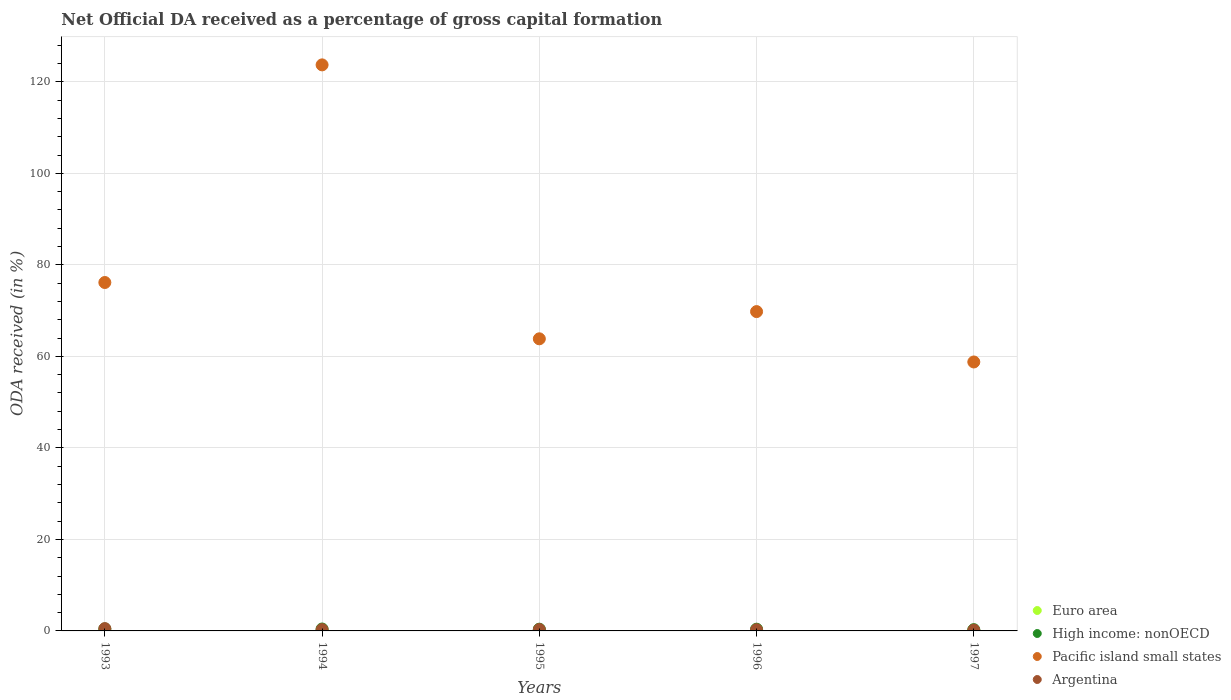How many different coloured dotlines are there?
Your answer should be compact. 4. What is the net ODA received in Argentina in 1997?
Provide a short and direct response. 0.18. Across all years, what is the maximum net ODA received in Argentina?
Offer a terse response. 0.5. Across all years, what is the minimum net ODA received in High income: nonOECD?
Provide a succinct answer. 0.28. In which year was the net ODA received in Euro area maximum?
Provide a succinct answer. 1996. In which year was the net ODA received in Euro area minimum?
Your answer should be compact. 1995. What is the total net ODA received in High income: nonOECD in the graph?
Your answer should be very brief. 1.9. What is the difference between the net ODA received in High income: nonOECD in 1994 and that in 1997?
Your response must be concise. 0.14. What is the difference between the net ODA received in Pacific island small states in 1994 and the net ODA received in Argentina in 1997?
Give a very brief answer. 123.53. What is the average net ODA received in Argentina per year?
Offer a very short reply. 0.31. In the year 1995, what is the difference between the net ODA received in Argentina and net ODA received in Pacific island small states?
Offer a terse response. -63.53. In how many years, is the net ODA received in High income: nonOECD greater than 72 %?
Offer a terse response. 0. What is the ratio of the net ODA received in Euro area in 1994 to that in 1996?
Make the answer very short. 0.77. What is the difference between the highest and the second highest net ODA received in Argentina?
Offer a terse response. 0.19. What is the difference between the highest and the lowest net ODA received in Euro area?
Your response must be concise. 0.01. In how many years, is the net ODA received in Euro area greater than the average net ODA received in Euro area taken over all years?
Keep it short and to the point. 3. Is the sum of the net ODA received in Pacific island small states in 1993 and 1997 greater than the maximum net ODA received in Argentina across all years?
Give a very brief answer. Yes. Is it the case that in every year, the sum of the net ODA received in Argentina and net ODA received in Pacific island small states  is greater than the net ODA received in High income: nonOECD?
Provide a succinct answer. Yes. How many years are there in the graph?
Give a very brief answer. 5. What is the difference between two consecutive major ticks on the Y-axis?
Your response must be concise. 20. Are the values on the major ticks of Y-axis written in scientific E-notation?
Ensure brevity in your answer.  No. Does the graph contain any zero values?
Give a very brief answer. No. Does the graph contain grids?
Offer a very short reply. Yes. Where does the legend appear in the graph?
Keep it short and to the point. Bottom right. How many legend labels are there?
Provide a short and direct response. 4. What is the title of the graph?
Ensure brevity in your answer.  Net Official DA received as a percentage of gross capital formation. Does "Switzerland" appear as one of the legend labels in the graph?
Ensure brevity in your answer.  No. What is the label or title of the X-axis?
Give a very brief answer. Years. What is the label or title of the Y-axis?
Provide a short and direct response. ODA received (in %). What is the ODA received (in %) in Euro area in 1993?
Provide a succinct answer. 0.01. What is the ODA received (in %) in High income: nonOECD in 1993?
Make the answer very short. 0.44. What is the ODA received (in %) in Pacific island small states in 1993?
Provide a short and direct response. 76.15. What is the ODA received (in %) of Argentina in 1993?
Provide a short and direct response. 0.5. What is the ODA received (in %) in Euro area in 1994?
Provide a succinct answer. 0.01. What is the ODA received (in %) of High income: nonOECD in 1994?
Your response must be concise. 0.42. What is the ODA received (in %) of Pacific island small states in 1994?
Your response must be concise. 123.71. What is the ODA received (in %) of Argentina in 1994?
Provide a succinct answer. 0.28. What is the ODA received (in %) in Euro area in 1995?
Provide a succinct answer. 0.01. What is the ODA received (in %) of High income: nonOECD in 1995?
Ensure brevity in your answer.  0.38. What is the ODA received (in %) of Pacific island small states in 1995?
Your answer should be very brief. 63.84. What is the ODA received (in %) of Argentina in 1995?
Your answer should be very brief. 0.31. What is the ODA received (in %) of Euro area in 1996?
Your answer should be very brief. 0.01. What is the ODA received (in %) in High income: nonOECD in 1996?
Provide a short and direct response. 0.38. What is the ODA received (in %) of Pacific island small states in 1996?
Give a very brief answer. 69.79. What is the ODA received (in %) of Argentina in 1996?
Ensure brevity in your answer.  0.27. What is the ODA received (in %) in Euro area in 1997?
Make the answer very short. 0.01. What is the ODA received (in %) in High income: nonOECD in 1997?
Offer a terse response. 0.28. What is the ODA received (in %) in Pacific island small states in 1997?
Provide a short and direct response. 58.78. What is the ODA received (in %) of Argentina in 1997?
Your response must be concise. 0.18. Across all years, what is the maximum ODA received (in %) of Euro area?
Ensure brevity in your answer.  0.01. Across all years, what is the maximum ODA received (in %) of High income: nonOECD?
Give a very brief answer. 0.44. Across all years, what is the maximum ODA received (in %) of Pacific island small states?
Your answer should be very brief. 123.71. Across all years, what is the maximum ODA received (in %) of Argentina?
Keep it short and to the point. 0.5. Across all years, what is the minimum ODA received (in %) of Euro area?
Ensure brevity in your answer.  0.01. Across all years, what is the minimum ODA received (in %) of High income: nonOECD?
Your response must be concise. 0.28. Across all years, what is the minimum ODA received (in %) in Pacific island small states?
Provide a short and direct response. 58.78. Across all years, what is the minimum ODA received (in %) in Argentina?
Give a very brief answer. 0.18. What is the total ODA received (in %) in Euro area in the graph?
Your answer should be compact. 0.04. What is the total ODA received (in %) of High income: nonOECD in the graph?
Offer a very short reply. 1.9. What is the total ODA received (in %) of Pacific island small states in the graph?
Give a very brief answer. 392.26. What is the total ODA received (in %) of Argentina in the graph?
Provide a succinct answer. 1.54. What is the difference between the ODA received (in %) of Euro area in 1993 and that in 1994?
Provide a succinct answer. -0. What is the difference between the ODA received (in %) of High income: nonOECD in 1993 and that in 1994?
Your response must be concise. 0.02. What is the difference between the ODA received (in %) of Pacific island small states in 1993 and that in 1994?
Your response must be concise. -47.56. What is the difference between the ODA received (in %) in Argentina in 1993 and that in 1994?
Your answer should be compact. 0.22. What is the difference between the ODA received (in %) of High income: nonOECD in 1993 and that in 1995?
Provide a short and direct response. 0.06. What is the difference between the ODA received (in %) of Pacific island small states in 1993 and that in 1995?
Make the answer very short. 12.31. What is the difference between the ODA received (in %) of Argentina in 1993 and that in 1995?
Provide a short and direct response. 0.19. What is the difference between the ODA received (in %) of Euro area in 1993 and that in 1996?
Your answer should be compact. -0.01. What is the difference between the ODA received (in %) of High income: nonOECD in 1993 and that in 1996?
Your answer should be compact. 0.06. What is the difference between the ODA received (in %) of Pacific island small states in 1993 and that in 1996?
Offer a terse response. 6.36. What is the difference between the ODA received (in %) of Argentina in 1993 and that in 1996?
Make the answer very short. 0.24. What is the difference between the ODA received (in %) of Euro area in 1993 and that in 1997?
Make the answer very short. -0. What is the difference between the ODA received (in %) of High income: nonOECD in 1993 and that in 1997?
Give a very brief answer. 0.16. What is the difference between the ODA received (in %) of Pacific island small states in 1993 and that in 1997?
Provide a succinct answer. 17.37. What is the difference between the ODA received (in %) of Argentina in 1993 and that in 1997?
Give a very brief answer. 0.32. What is the difference between the ODA received (in %) of Euro area in 1994 and that in 1995?
Ensure brevity in your answer.  0. What is the difference between the ODA received (in %) of High income: nonOECD in 1994 and that in 1995?
Offer a terse response. 0.04. What is the difference between the ODA received (in %) in Pacific island small states in 1994 and that in 1995?
Give a very brief answer. 59.87. What is the difference between the ODA received (in %) in Argentina in 1994 and that in 1995?
Offer a terse response. -0.02. What is the difference between the ODA received (in %) in Euro area in 1994 and that in 1996?
Provide a short and direct response. -0. What is the difference between the ODA received (in %) in High income: nonOECD in 1994 and that in 1996?
Offer a terse response. 0.04. What is the difference between the ODA received (in %) in Pacific island small states in 1994 and that in 1996?
Give a very brief answer. 53.92. What is the difference between the ODA received (in %) in Argentina in 1994 and that in 1996?
Ensure brevity in your answer.  0.02. What is the difference between the ODA received (in %) in Euro area in 1994 and that in 1997?
Make the answer very short. 0. What is the difference between the ODA received (in %) of High income: nonOECD in 1994 and that in 1997?
Provide a short and direct response. 0.14. What is the difference between the ODA received (in %) of Pacific island small states in 1994 and that in 1997?
Your answer should be compact. 64.93. What is the difference between the ODA received (in %) of Argentina in 1994 and that in 1997?
Offer a very short reply. 0.1. What is the difference between the ODA received (in %) of Euro area in 1995 and that in 1996?
Provide a short and direct response. -0.01. What is the difference between the ODA received (in %) of High income: nonOECD in 1995 and that in 1996?
Provide a succinct answer. -0. What is the difference between the ODA received (in %) of Pacific island small states in 1995 and that in 1996?
Your answer should be very brief. -5.95. What is the difference between the ODA received (in %) in Argentina in 1995 and that in 1996?
Keep it short and to the point. 0.04. What is the difference between the ODA received (in %) in Euro area in 1995 and that in 1997?
Make the answer very short. -0. What is the difference between the ODA received (in %) of High income: nonOECD in 1995 and that in 1997?
Offer a very short reply. 0.1. What is the difference between the ODA received (in %) of Pacific island small states in 1995 and that in 1997?
Provide a succinct answer. 5.06. What is the difference between the ODA received (in %) in Argentina in 1995 and that in 1997?
Provide a succinct answer. 0.13. What is the difference between the ODA received (in %) in Euro area in 1996 and that in 1997?
Your response must be concise. 0. What is the difference between the ODA received (in %) in High income: nonOECD in 1996 and that in 1997?
Keep it short and to the point. 0.1. What is the difference between the ODA received (in %) in Pacific island small states in 1996 and that in 1997?
Offer a terse response. 11.01. What is the difference between the ODA received (in %) of Argentina in 1996 and that in 1997?
Provide a short and direct response. 0.09. What is the difference between the ODA received (in %) of Euro area in 1993 and the ODA received (in %) of High income: nonOECD in 1994?
Give a very brief answer. -0.41. What is the difference between the ODA received (in %) in Euro area in 1993 and the ODA received (in %) in Pacific island small states in 1994?
Your answer should be very brief. -123.7. What is the difference between the ODA received (in %) of Euro area in 1993 and the ODA received (in %) of Argentina in 1994?
Ensure brevity in your answer.  -0.28. What is the difference between the ODA received (in %) in High income: nonOECD in 1993 and the ODA received (in %) in Pacific island small states in 1994?
Your answer should be very brief. -123.27. What is the difference between the ODA received (in %) in High income: nonOECD in 1993 and the ODA received (in %) in Argentina in 1994?
Provide a succinct answer. 0.15. What is the difference between the ODA received (in %) in Pacific island small states in 1993 and the ODA received (in %) in Argentina in 1994?
Keep it short and to the point. 75.86. What is the difference between the ODA received (in %) in Euro area in 1993 and the ODA received (in %) in High income: nonOECD in 1995?
Offer a very short reply. -0.37. What is the difference between the ODA received (in %) of Euro area in 1993 and the ODA received (in %) of Pacific island small states in 1995?
Your answer should be very brief. -63.83. What is the difference between the ODA received (in %) of Euro area in 1993 and the ODA received (in %) of Argentina in 1995?
Make the answer very short. -0.3. What is the difference between the ODA received (in %) in High income: nonOECD in 1993 and the ODA received (in %) in Pacific island small states in 1995?
Offer a terse response. -63.4. What is the difference between the ODA received (in %) in High income: nonOECD in 1993 and the ODA received (in %) in Argentina in 1995?
Give a very brief answer. 0.13. What is the difference between the ODA received (in %) of Pacific island small states in 1993 and the ODA received (in %) of Argentina in 1995?
Make the answer very short. 75.84. What is the difference between the ODA received (in %) of Euro area in 1993 and the ODA received (in %) of High income: nonOECD in 1996?
Provide a succinct answer. -0.38. What is the difference between the ODA received (in %) in Euro area in 1993 and the ODA received (in %) in Pacific island small states in 1996?
Offer a very short reply. -69.78. What is the difference between the ODA received (in %) of Euro area in 1993 and the ODA received (in %) of Argentina in 1996?
Your answer should be compact. -0.26. What is the difference between the ODA received (in %) in High income: nonOECD in 1993 and the ODA received (in %) in Pacific island small states in 1996?
Ensure brevity in your answer.  -69.35. What is the difference between the ODA received (in %) in High income: nonOECD in 1993 and the ODA received (in %) in Argentina in 1996?
Give a very brief answer. 0.17. What is the difference between the ODA received (in %) of Pacific island small states in 1993 and the ODA received (in %) of Argentina in 1996?
Your answer should be compact. 75.88. What is the difference between the ODA received (in %) of Euro area in 1993 and the ODA received (in %) of High income: nonOECD in 1997?
Provide a succinct answer. -0.27. What is the difference between the ODA received (in %) of Euro area in 1993 and the ODA received (in %) of Pacific island small states in 1997?
Ensure brevity in your answer.  -58.77. What is the difference between the ODA received (in %) in Euro area in 1993 and the ODA received (in %) in Argentina in 1997?
Your answer should be compact. -0.17. What is the difference between the ODA received (in %) in High income: nonOECD in 1993 and the ODA received (in %) in Pacific island small states in 1997?
Give a very brief answer. -58.34. What is the difference between the ODA received (in %) in High income: nonOECD in 1993 and the ODA received (in %) in Argentina in 1997?
Your response must be concise. 0.26. What is the difference between the ODA received (in %) in Pacific island small states in 1993 and the ODA received (in %) in Argentina in 1997?
Give a very brief answer. 75.97. What is the difference between the ODA received (in %) in Euro area in 1994 and the ODA received (in %) in High income: nonOECD in 1995?
Your answer should be compact. -0.37. What is the difference between the ODA received (in %) in Euro area in 1994 and the ODA received (in %) in Pacific island small states in 1995?
Ensure brevity in your answer.  -63.83. What is the difference between the ODA received (in %) in Euro area in 1994 and the ODA received (in %) in Argentina in 1995?
Offer a terse response. -0.3. What is the difference between the ODA received (in %) of High income: nonOECD in 1994 and the ODA received (in %) of Pacific island small states in 1995?
Provide a short and direct response. -63.42. What is the difference between the ODA received (in %) in High income: nonOECD in 1994 and the ODA received (in %) in Argentina in 1995?
Offer a very short reply. 0.11. What is the difference between the ODA received (in %) in Pacific island small states in 1994 and the ODA received (in %) in Argentina in 1995?
Make the answer very short. 123.4. What is the difference between the ODA received (in %) of Euro area in 1994 and the ODA received (in %) of High income: nonOECD in 1996?
Give a very brief answer. -0.37. What is the difference between the ODA received (in %) of Euro area in 1994 and the ODA received (in %) of Pacific island small states in 1996?
Your response must be concise. -69.78. What is the difference between the ODA received (in %) in Euro area in 1994 and the ODA received (in %) in Argentina in 1996?
Your answer should be very brief. -0.26. What is the difference between the ODA received (in %) in High income: nonOECD in 1994 and the ODA received (in %) in Pacific island small states in 1996?
Provide a short and direct response. -69.37. What is the difference between the ODA received (in %) in High income: nonOECD in 1994 and the ODA received (in %) in Argentina in 1996?
Offer a very short reply. 0.15. What is the difference between the ODA received (in %) of Pacific island small states in 1994 and the ODA received (in %) of Argentina in 1996?
Give a very brief answer. 123.44. What is the difference between the ODA received (in %) in Euro area in 1994 and the ODA received (in %) in High income: nonOECD in 1997?
Give a very brief answer. -0.27. What is the difference between the ODA received (in %) in Euro area in 1994 and the ODA received (in %) in Pacific island small states in 1997?
Offer a terse response. -58.77. What is the difference between the ODA received (in %) in Euro area in 1994 and the ODA received (in %) in Argentina in 1997?
Offer a very short reply. -0.17. What is the difference between the ODA received (in %) in High income: nonOECD in 1994 and the ODA received (in %) in Pacific island small states in 1997?
Keep it short and to the point. -58.36. What is the difference between the ODA received (in %) in High income: nonOECD in 1994 and the ODA received (in %) in Argentina in 1997?
Offer a terse response. 0.24. What is the difference between the ODA received (in %) in Pacific island small states in 1994 and the ODA received (in %) in Argentina in 1997?
Give a very brief answer. 123.53. What is the difference between the ODA received (in %) of Euro area in 1995 and the ODA received (in %) of High income: nonOECD in 1996?
Make the answer very short. -0.38. What is the difference between the ODA received (in %) in Euro area in 1995 and the ODA received (in %) in Pacific island small states in 1996?
Make the answer very short. -69.78. What is the difference between the ODA received (in %) of Euro area in 1995 and the ODA received (in %) of Argentina in 1996?
Offer a terse response. -0.26. What is the difference between the ODA received (in %) of High income: nonOECD in 1995 and the ODA received (in %) of Pacific island small states in 1996?
Your response must be concise. -69.41. What is the difference between the ODA received (in %) in High income: nonOECD in 1995 and the ODA received (in %) in Argentina in 1996?
Your response must be concise. 0.11. What is the difference between the ODA received (in %) of Pacific island small states in 1995 and the ODA received (in %) of Argentina in 1996?
Provide a succinct answer. 63.57. What is the difference between the ODA received (in %) of Euro area in 1995 and the ODA received (in %) of High income: nonOECD in 1997?
Keep it short and to the point. -0.27. What is the difference between the ODA received (in %) in Euro area in 1995 and the ODA received (in %) in Pacific island small states in 1997?
Your answer should be very brief. -58.77. What is the difference between the ODA received (in %) in Euro area in 1995 and the ODA received (in %) in Argentina in 1997?
Make the answer very short. -0.17. What is the difference between the ODA received (in %) of High income: nonOECD in 1995 and the ODA received (in %) of Pacific island small states in 1997?
Offer a very short reply. -58.4. What is the difference between the ODA received (in %) in High income: nonOECD in 1995 and the ODA received (in %) in Argentina in 1997?
Your answer should be compact. 0.2. What is the difference between the ODA received (in %) of Pacific island small states in 1995 and the ODA received (in %) of Argentina in 1997?
Keep it short and to the point. 63.66. What is the difference between the ODA received (in %) of Euro area in 1996 and the ODA received (in %) of High income: nonOECD in 1997?
Your answer should be compact. -0.27. What is the difference between the ODA received (in %) in Euro area in 1996 and the ODA received (in %) in Pacific island small states in 1997?
Offer a very short reply. -58.77. What is the difference between the ODA received (in %) of Euro area in 1996 and the ODA received (in %) of Argentina in 1997?
Give a very brief answer. -0.17. What is the difference between the ODA received (in %) of High income: nonOECD in 1996 and the ODA received (in %) of Pacific island small states in 1997?
Give a very brief answer. -58.4. What is the difference between the ODA received (in %) in High income: nonOECD in 1996 and the ODA received (in %) in Argentina in 1997?
Offer a terse response. 0.2. What is the difference between the ODA received (in %) in Pacific island small states in 1996 and the ODA received (in %) in Argentina in 1997?
Make the answer very short. 69.61. What is the average ODA received (in %) in Euro area per year?
Keep it short and to the point. 0.01. What is the average ODA received (in %) in High income: nonOECD per year?
Provide a succinct answer. 0.38. What is the average ODA received (in %) of Pacific island small states per year?
Keep it short and to the point. 78.45. What is the average ODA received (in %) of Argentina per year?
Offer a very short reply. 0.31. In the year 1993, what is the difference between the ODA received (in %) in Euro area and ODA received (in %) in High income: nonOECD?
Offer a very short reply. -0.43. In the year 1993, what is the difference between the ODA received (in %) in Euro area and ODA received (in %) in Pacific island small states?
Ensure brevity in your answer.  -76.14. In the year 1993, what is the difference between the ODA received (in %) of Euro area and ODA received (in %) of Argentina?
Offer a terse response. -0.5. In the year 1993, what is the difference between the ODA received (in %) in High income: nonOECD and ODA received (in %) in Pacific island small states?
Offer a terse response. -75.71. In the year 1993, what is the difference between the ODA received (in %) of High income: nonOECD and ODA received (in %) of Argentina?
Provide a succinct answer. -0.06. In the year 1993, what is the difference between the ODA received (in %) in Pacific island small states and ODA received (in %) in Argentina?
Make the answer very short. 75.64. In the year 1994, what is the difference between the ODA received (in %) of Euro area and ODA received (in %) of High income: nonOECD?
Provide a short and direct response. -0.41. In the year 1994, what is the difference between the ODA received (in %) of Euro area and ODA received (in %) of Pacific island small states?
Offer a very short reply. -123.7. In the year 1994, what is the difference between the ODA received (in %) of Euro area and ODA received (in %) of Argentina?
Offer a very short reply. -0.28. In the year 1994, what is the difference between the ODA received (in %) in High income: nonOECD and ODA received (in %) in Pacific island small states?
Offer a very short reply. -123.29. In the year 1994, what is the difference between the ODA received (in %) in High income: nonOECD and ODA received (in %) in Argentina?
Ensure brevity in your answer.  0.14. In the year 1994, what is the difference between the ODA received (in %) of Pacific island small states and ODA received (in %) of Argentina?
Your answer should be compact. 123.42. In the year 1995, what is the difference between the ODA received (in %) in Euro area and ODA received (in %) in High income: nonOECD?
Provide a succinct answer. -0.38. In the year 1995, what is the difference between the ODA received (in %) of Euro area and ODA received (in %) of Pacific island small states?
Offer a very short reply. -63.84. In the year 1995, what is the difference between the ODA received (in %) in Euro area and ODA received (in %) in Argentina?
Make the answer very short. -0.3. In the year 1995, what is the difference between the ODA received (in %) of High income: nonOECD and ODA received (in %) of Pacific island small states?
Your answer should be very brief. -63.46. In the year 1995, what is the difference between the ODA received (in %) in High income: nonOECD and ODA received (in %) in Argentina?
Make the answer very short. 0.07. In the year 1995, what is the difference between the ODA received (in %) of Pacific island small states and ODA received (in %) of Argentina?
Your response must be concise. 63.53. In the year 1996, what is the difference between the ODA received (in %) in Euro area and ODA received (in %) in High income: nonOECD?
Provide a succinct answer. -0.37. In the year 1996, what is the difference between the ODA received (in %) in Euro area and ODA received (in %) in Pacific island small states?
Your response must be concise. -69.78. In the year 1996, what is the difference between the ODA received (in %) in Euro area and ODA received (in %) in Argentina?
Provide a short and direct response. -0.25. In the year 1996, what is the difference between the ODA received (in %) in High income: nonOECD and ODA received (in %) in Pacific island small states?
Provide a short and direct response. -69.41. In the year 1996, what is the difference between the ODA received (in %) of High income: nonOECD and ODA received (in %) of Argentina?
Provide a succinct answer. 0.12. In the year 1996, what is the difference between the ODA received (in %) of Pacific island small states and ODA received (in %) of Argentina?
Provide a short and direct response. 69.52. In the year 1997, what is the difference between the ODA received (in %) of Euro area and ODA received (in %) of High income: nonOECD?
Your answer should be compact. -0.27. In the year 1997, what is the difference between the ODA received (in %) in Euro area and ODA received (in %) in Pacific island small states?
Your answer should be very brief. -58.77. In the year 1997, what is the difference between the ODA received (in %) of Euro area and ODA received (in %) of Argentina?
Give a very brief answer. -0.17. In the year 1997, what is the difference between the ODA received (in %) of High income: nonOECD and ODA received (in %) of Pacific island small states?
Ensure brevity in your answer.  -58.5. In the year 1997, what is the difference between the ODA received (in %) of High income: nonOECD and ODA received (in %) of Argentina?
Offer a very short reply. 0.1. In the year 1997, what is the difference between the ODA received (in %) of Pacific island small states and ODA received (in %) of Argentina?
Your response must be concise. 58.6. What is the ratio of the ODA received (in %) of Euro area in 1993 to that in 1994?
Make the answer very short. 0.65. What is the ratio of the ODA received (in %) in High income: nonOECD in 1993 to that in 1994?
Offer a very short reply. 1.04. What is the ratio of the ODA received (in %) of Pacific island small states in 1993 to that in 1994?
Make the answer very short. 0.62. What is the ratio of the ODA received (in %) in Argentina in 1993 to that in 1994?
Offer a very short reply. 1.76. What is the ratio of the ODA received (in %) in Euro area in 1993 to that in 1995?
Provide a short and direct response. 1.09. What is the ratio of the ODA received (in %) of High income: nonOECD in 1993 to that in 1995?
Keep it short and to the point. 1.15. What is the ratio of the ODA received (in %) in Pacific island small states in 1993 to that in 1995?
Provide a short and direct response. 1.19. What is the ratio of the ODA received (in %) in Argentina in 1993 to that in 1995?
Ensure brevity in your answer.  1.63. What is the ratio of the ODA received (in %) of Euro area in 1993 to that in 1996?
Give a very brief answer. 0.5. What is the ratio of the ODA received (in %) of High income: nonOECD in 1993 to that in 1996?
Your answer should be compact. 1.15. What is the ratio of the ODA received (in %) in Pacific island small states in 1993 to that in 1996?
Ensure brevity in your answer.  1.09. What is the ratio of the ODA received (in %) in Argentina in 1993 to that in 1996?
Your response must be concise. 1.89. What is the ratio of the ODA received (in %) of Euro area in 1993 to that in 1997?
Offer a terse response. 0.69. What is the ratio of the ODA received (in %) in High income: nonOECD in 1993 to that in 1997?
Keep it short and to the point. 1.58. What is the ratio of the ODA received (in %) in Pacific island small states in 1993 to that in 1997?
Provide a short and direct response. 1.3. What is the ratio of the ODA received (in %) in Argentina in 1993 to that in 1997?
Provide a succinct answer. 2.79. What is the ratio of the ODA received (in %) in Euro area in 1994 to that in 1995?
Offer a terse response. 1.67. What is the ratio of the ODA received (in %) in High income: nonOECD in 1994 to that in 1995?
Keep it short and to the point. 1.11. What is the ratio of the ODA received (in %) of Pacific island small states in 1994 to that in 1995?
Make the answer very short. 1.94. What is the ratio of the ODA received (in %) of Argentina in 1994 to that in 1995?
Make the answer very short. 0.92. What is the ratio of the ODA received (in %) in Euro area in 1994 to that in 1996?
Your answer should be very brief. 0.77. What is the ratio of the ODA received (in %) in High income: nonOECD in 1994 to that in 1996?
Your answer should be compact. 1.1. What is the ratio of the ODA received (in %) in Pacific island small states in 1994 to that in 1996?
Provide a succinct answer. 1.77. What is the ratio of the ODA received (in %) in Argentina in 1994 to that in 1996?
Keep it short and to the point. 1.07. What is the ratio of the ODA received (in %) in Euro area in 1994 to that in 1997?
Give a very brief answer. 1.06. What is the ratio of the ODA received (in %) in High income: nonOECD in 1994 to that in 1997?
Keep it short and to the point. 1.51. What is the ratio of the ODA received (in %) of Pacific island small states in 1994 to that in 1997?
Provide a succinct answer. 2.1. What is the ratio of the ODA received (in %) in Argentina in 1994 to that in 1997?
Make the answer very short. 1.58. What is the ratio of the ODA received (in %) of Euro area in 1995 to that in 1996?
Your answer should be very brief. 0.46. What is the ratio of the ODA received (in %) in High income: nonOECD in 1995 to that in 1996?
Offer a very short reply. 0.99. What is the ratio of the ODA received (in %) in Pacific island small states in 1995 to that in 1996?
Provide a succinct answer. 0.91. What is the ratio of the ODA received (in %) of Argentina in 1995 to that in 1996?
Your response must be concise. 1.16. What is the ratio of the ODA received (in %) in Euro area in 1995 to that in 1997?
Your response must be concise. 0.63. What is the ratio of the ODA received (in %) in High income: nonOECD in 1995 to that in 1997?
Offer a very short reply. 1.37. What is the ratio of the ODA received (in %) of Pacific island small states in 1995 to that in 1997?
Your answer should be very brief. 1.09. What is the ratio of the ODA received (in %) in Argentina in 1995 to that in 1997?
Provide a succinct answer. 1.71. What is the ratio of the ODA received (in %) of Euro area in 1996 to that in 1997?
Make the answer very short. 1.37. What is the ratio of the ODA received (in %) of High income: nonOECD in 1996 to that in 1997?
Give a very brief answer. 1.38. What is the ratio of the ODA received (in %) of Pacific island small states in 1996 to that in 1997?
Provide a succinct answer. 1.19. What is the ratio of the ODA received (in %) of Argentina in 1996 to that in 1997?
Give a very brief answer. 1.48. What is the difference between the highest and the second highest ODA received (in %) in Euro area?
Your response must be concise. 0. What is the difference between the highest and the second highest ODA received (in %) of High income: nonOECD?
Keep it short and to the point. 0.02. What is the difference between the highest and the second highest ODA received (in %) of Pacific island small states?
Provide a succinct answer. 47.56. What is the difference between the highest and the second highest ODA received (in %) in Argentina?
Your answer should be compact. 0.19. What is the difference between the highest and the lowest ODA received (in %) in Euro area?
Give a very brief answer. 0.01. What is the difference between the highest and the lowest ODA received (in %) in High income: nonOECD?
Your answer should be compact. 0.16. What is the difference between the highest and the lowest ODA received (in %) in Pacific island small states?
Offer a terse response. 64.93. What is the difference between the highest and the lowest ODA received (in %) of Argentina?
Offer a very short reply. 0.32. 